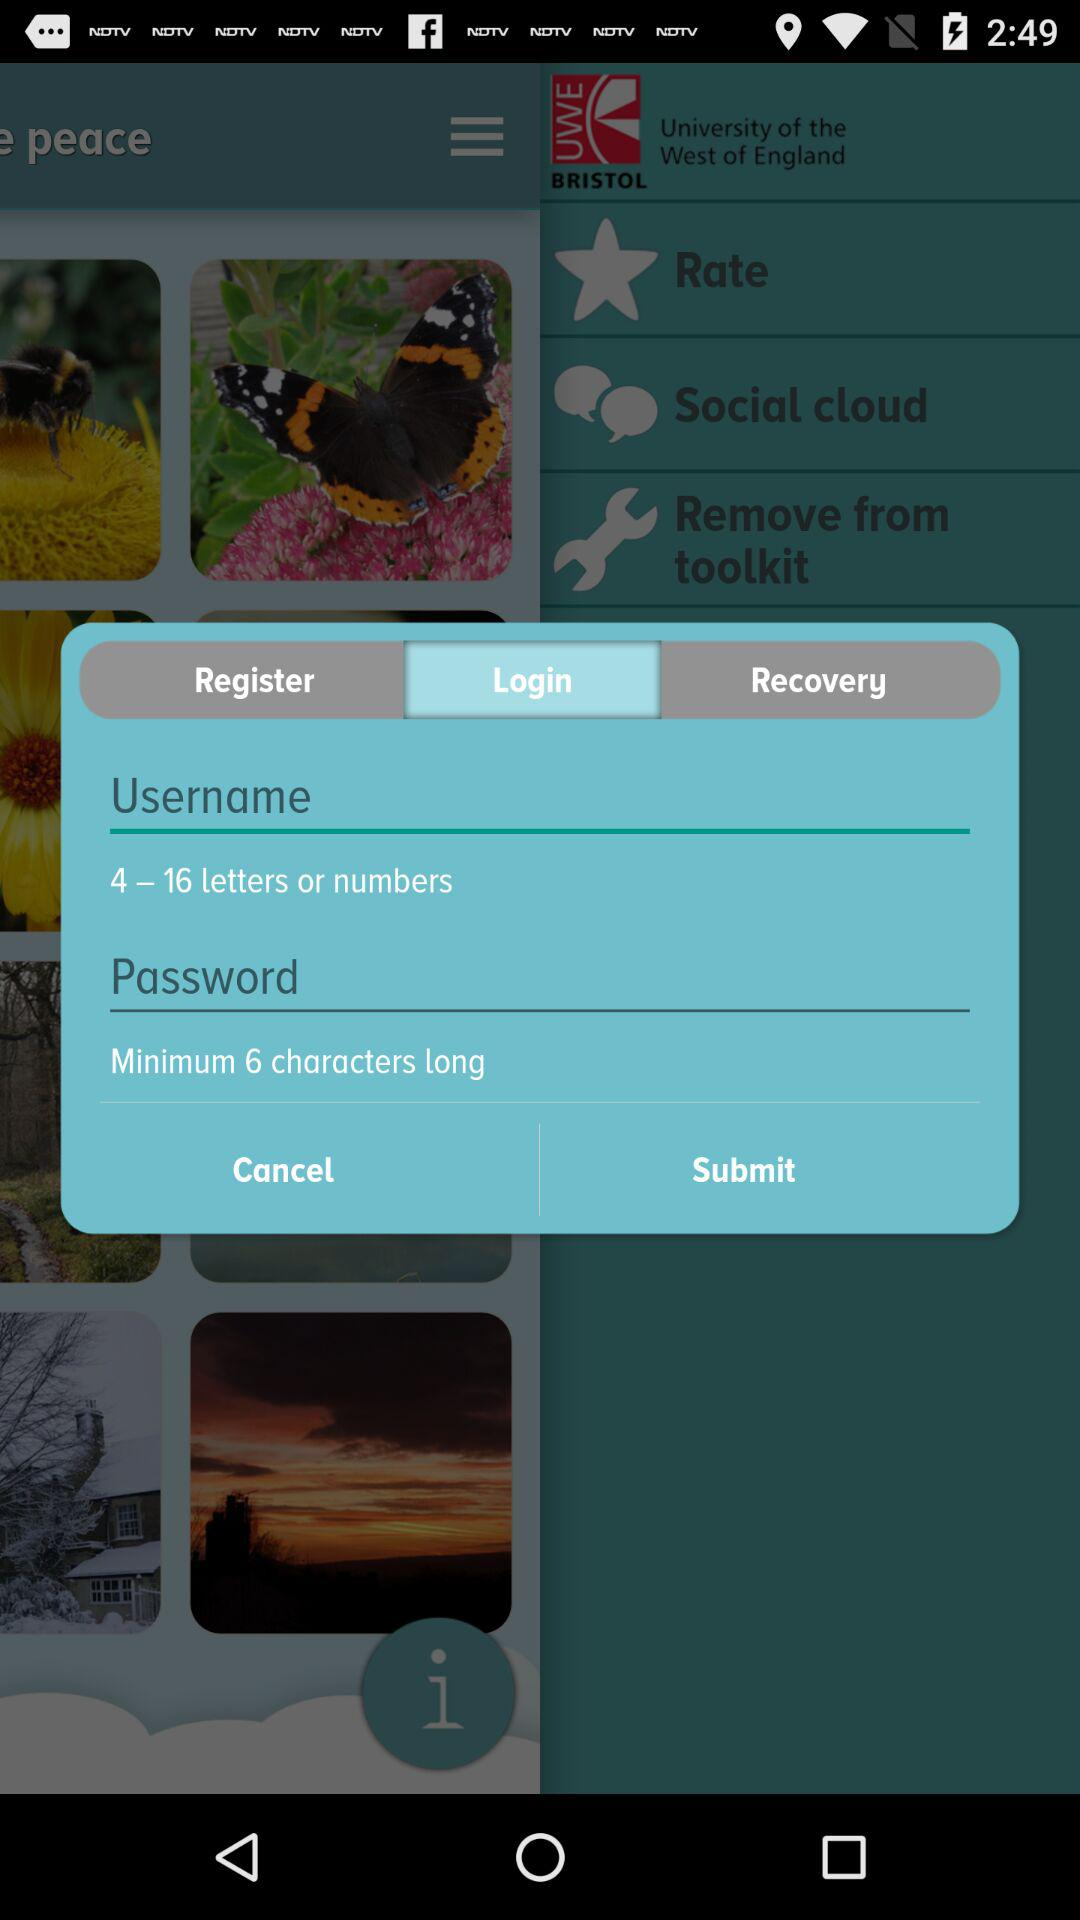What tab is selected? The selected tab is "Login". 